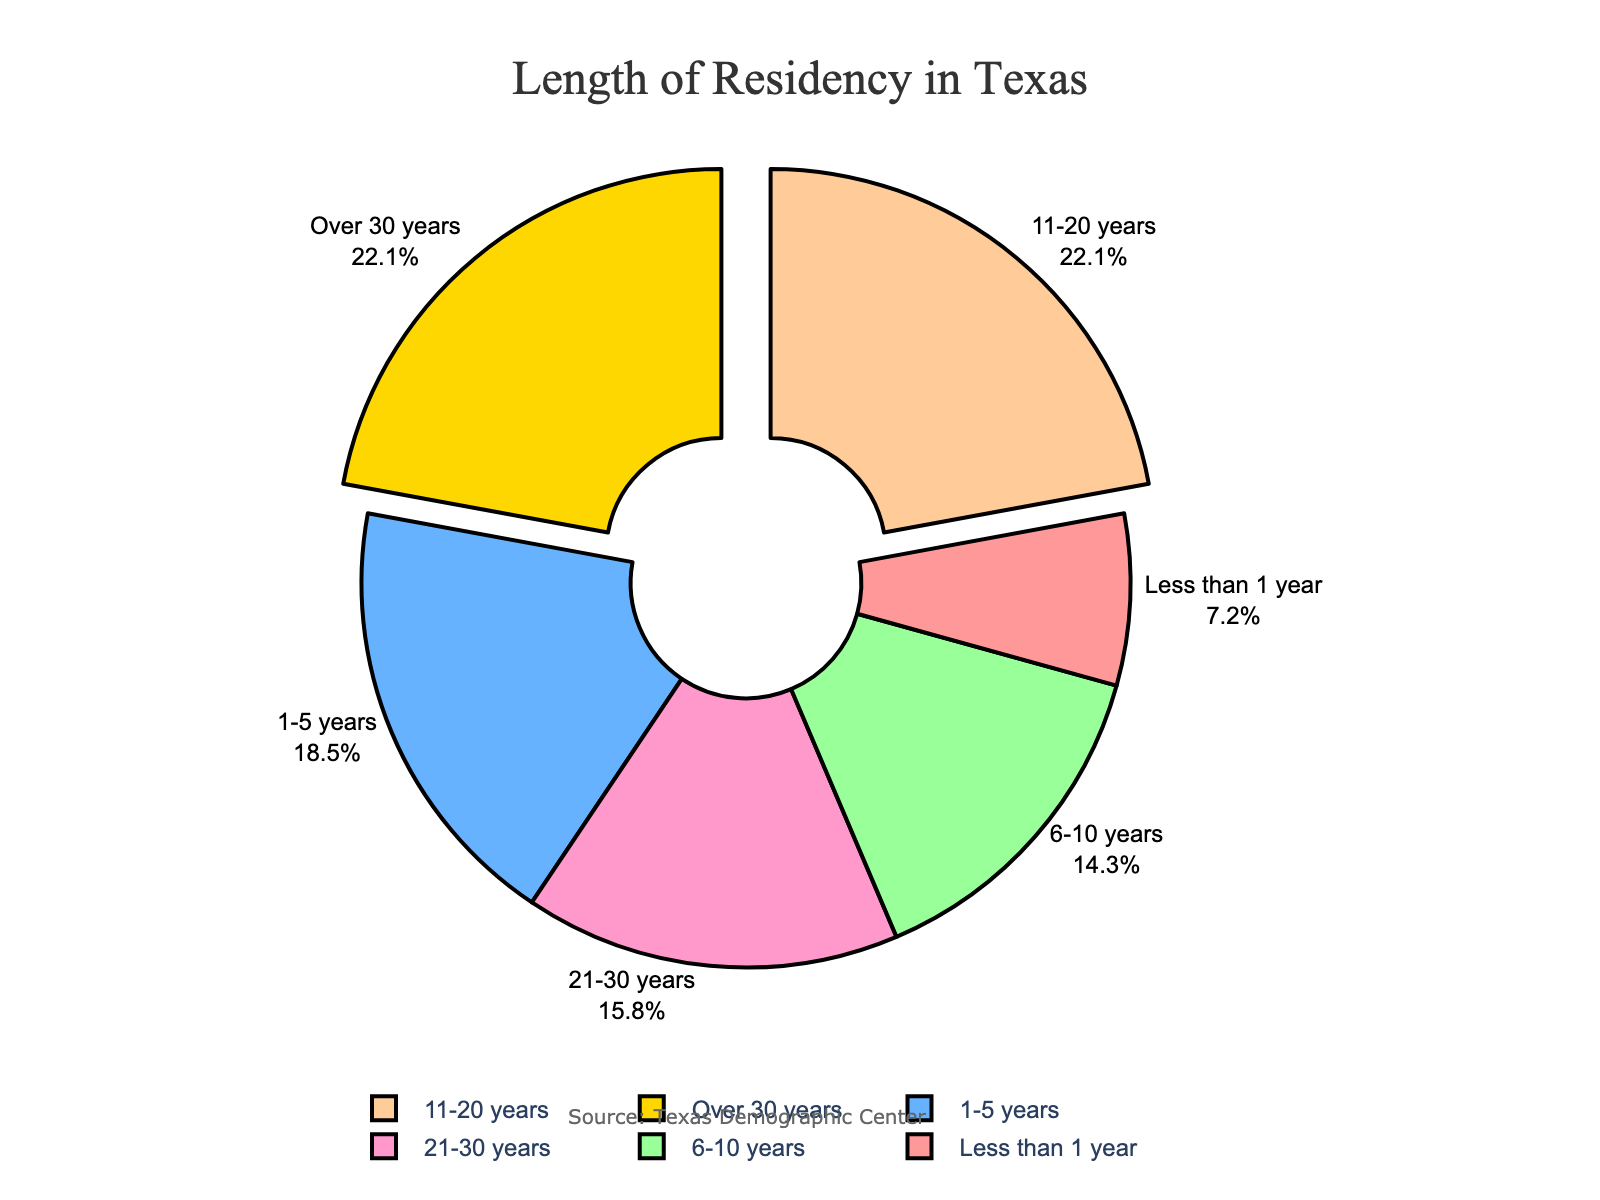What percentage of Texas residents have lived in Texas for less than 1 year? The section labeled "Less than 1 year" in the pie chart represents 7.2% of Texas residents.
Answer: 7.2% Which residency length has the highest percentage of Texas residents? The pie chart shows that both "11-20 years" and "Over 30 years" have the highest percentages of 22.1%.
Answer: 11-20 years and Over 30 years How much greater is the percentage of residents who have lived in Texas for 11-20 years compared to those who have lived less than 1 year? The percentage for "11-20 years" is 22.1% and for "Less than 1 year" is 7.2%. Subtract 7.2 from 22.1.
Answer: 14.9% What is the combined percentage of residents who have lived in Texas for 1-5 years and 6-10 years? The percentages for "1-5 years" and "6-10 years" are 18.5% and 14.3%, respectively. Add them together.
Answer: 32.8% Which color represents the residents with the shortest length of residency? The section representing "Less than 1 year" is depicted in red.
Answer: Red How does the percentage of residents who have lived in Texas for over 30 years compare to those who have lived for 21-30 years? Both the "Over 30 years" and "21-30 years" sections' percentages are given as 22.1% and 15.8%, respectively. The percentage of residents who have lived over 30 years is higher by 6.3%.
Answer: 6.3% higher How many residency lengths have a percentage greater than 20%? By examining the chart, two sections ("11-20 years" and "Over 30 years") each have percentages greater than 20%.
Answer: 2 If one were to move to Texas, which length of residency would they be placed in if they lived there for 5 years? By observing the labels, living in Texas for 5 years places one in the "1-5 years" category.
Answer: 1-5 years What is the difference in percentage between residents who have lived in Texas for 6-10 years and those who have lived there for 11-20 years? The percentages of residents for "6-10 years" and "11-20 years" are 14.3% and 22.1%, respectively. Subtract 14.3 from 22.1.
Answer: 7.8% 